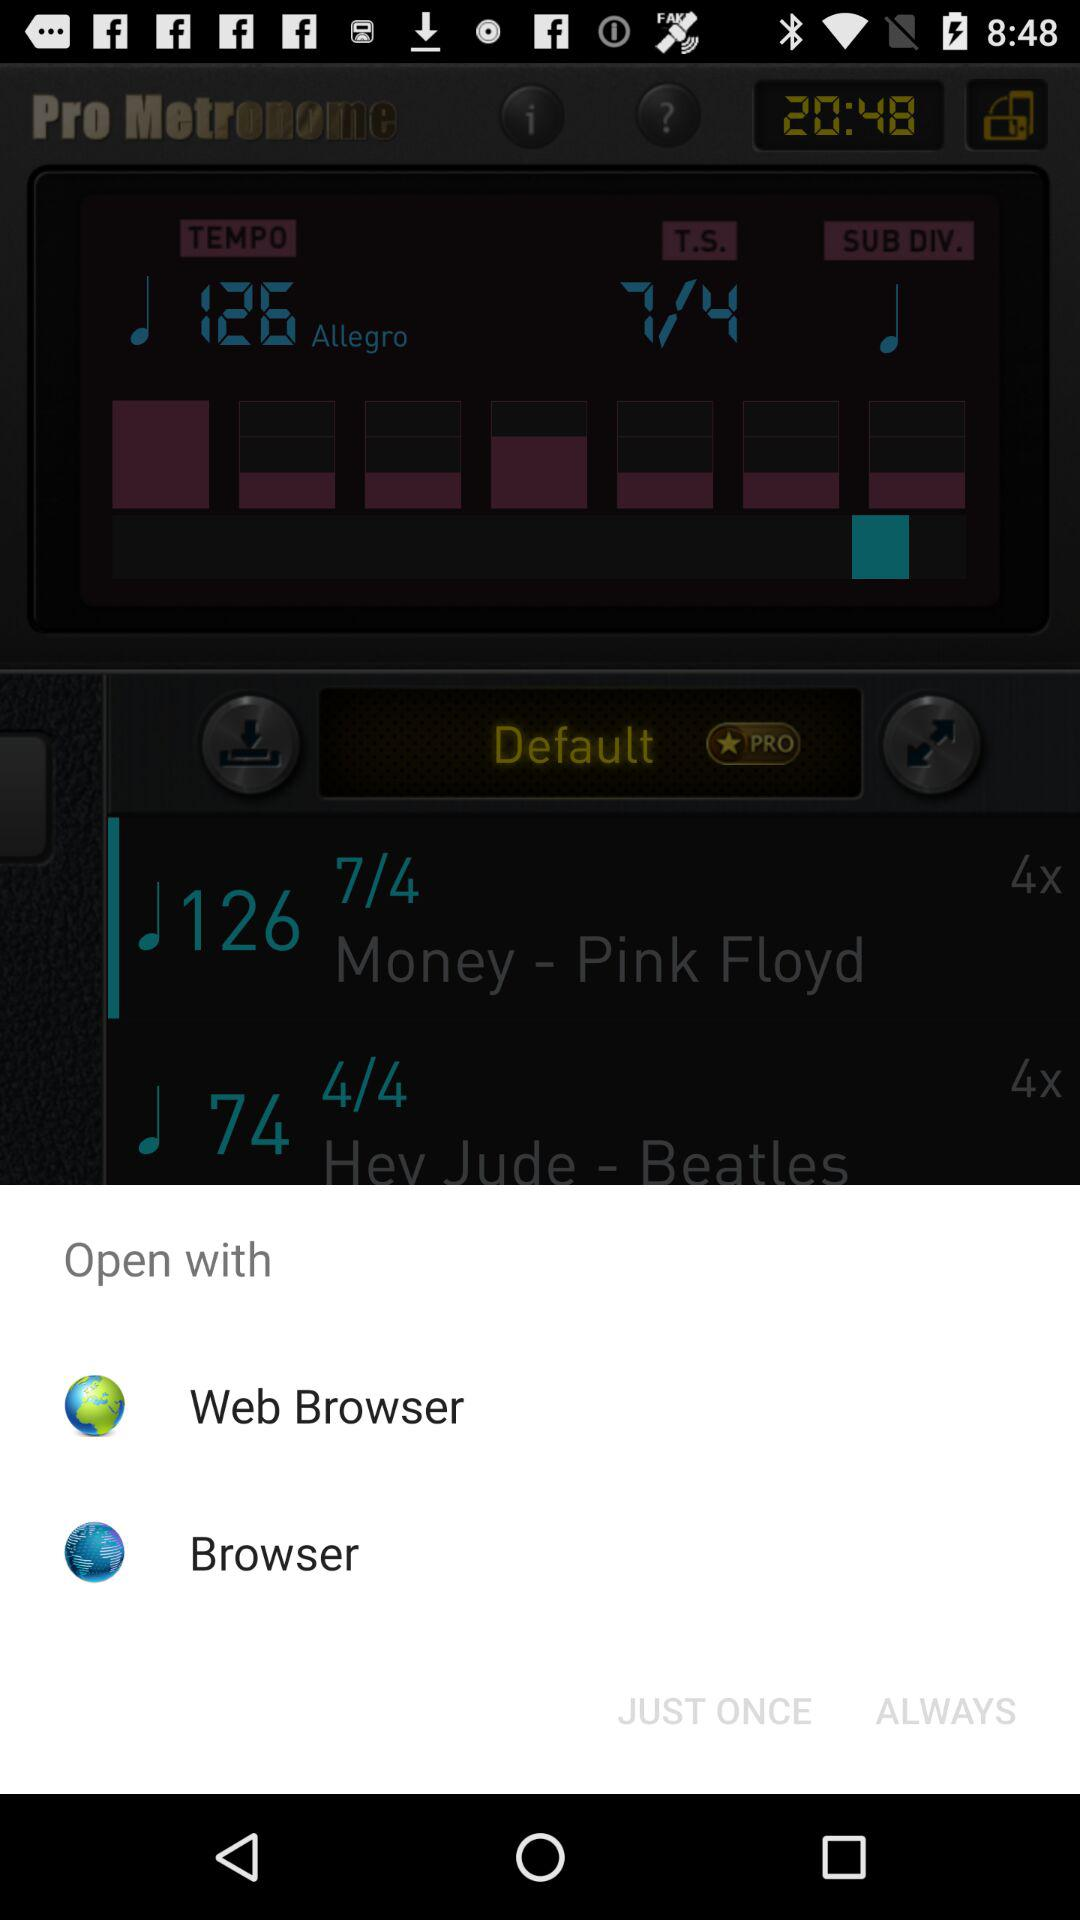What are the options to open the content? The options are "Web Browser" and "Browser". 